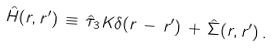<formula> <loc_0><loc_0><loc_500><loc_500>\hat { H } ( { r } , { r } ^ { \prime } ) \, \equiv \, \hat { \tau } _ { 3 } K \delta ( { r } \, - \, { r } ^ { \prime } ) \, + \, \hat { \Sigma } ( { r } , { r } ^ { \prime } ) \, .</formula> 